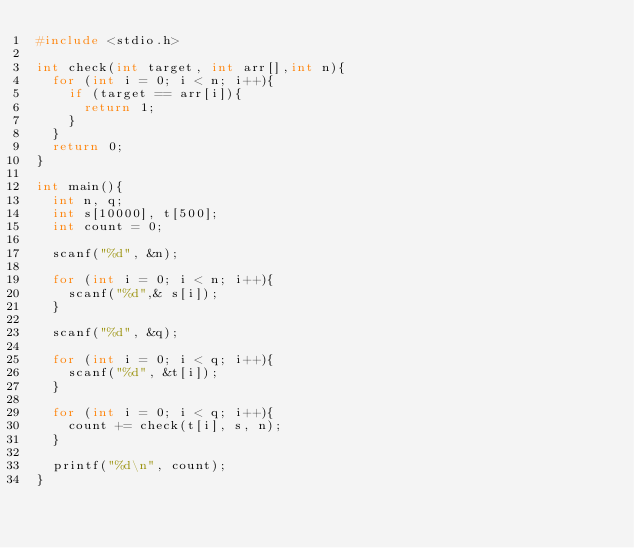<code> <loc_0><loc_0><loc_500><loc_500><_C_>#include <stdio.h>

int check(int target, int arr[],int n){
	for (int i = 0; i < n; i++){
		if (target == arr[i]){
			return 1;
		}
	}
	return 0;
}

int main(){
	int n, q;
	int s[10000], t[500];
	int count = 0;

	scanf("%d", &n);

	for (int i = 0; i < n; i++){
		scanf("%d",& s[i]);
	}

	scanf("%d", &q);

	for (int i = 0; i < q; i++){
		scanf("%d", &t[i]);
	}

	for (int i = 0; i < q; i++){
		count += check(t[i], s, n);
	}

	printf("%d\n", count);
}
</code> 